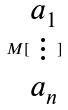Convert formula to latex. <formula><loc_0><loc_0><loc_500><loc_500>M [ \begin{matrix} a _ { 1 } \\ \vdots \\ a _ { n } \end{matrix} ]</formula> 